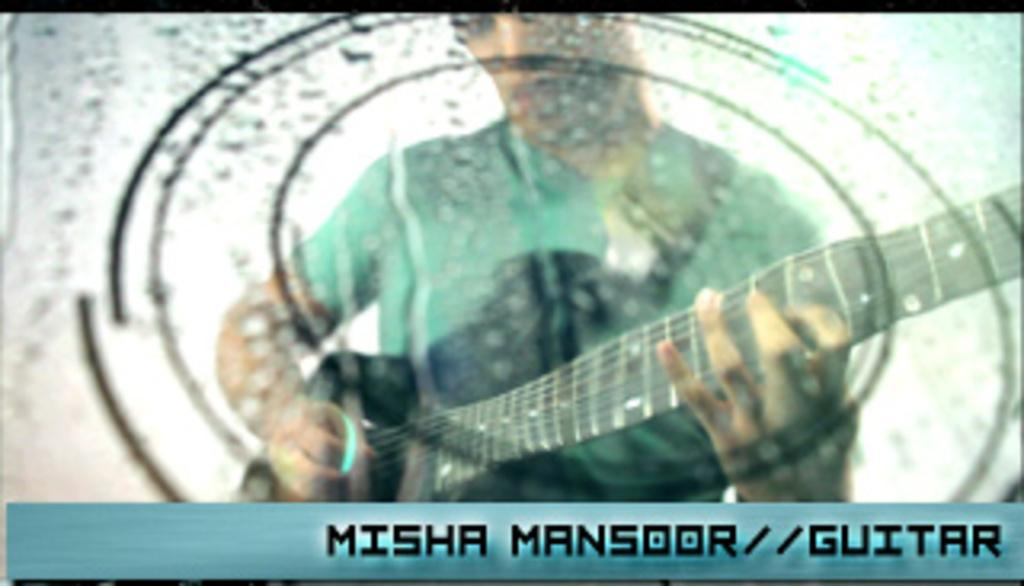What is the person in the image doing? The person is playing a guitar. Can you describe the activity the person is engaged in? The person is playing a musical instrument, specifically a guitar. Is there any other element in the image besides the person and the guitar? Yes, there is a watermark in the image. What type of pot is being used to cook breakfast in the image? There is no pot or breakfast present in the image; it only features a person playing a guitar and a watermark. 